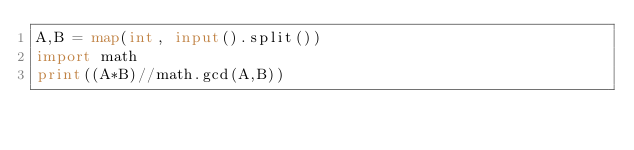Convert code to text. <code><loc_0><loc_0><loc_500><loc_500><_Python_>A,B = map(int, input().split())
import math
print((A*B)//math.gcd(A,B))</code> 